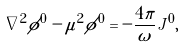Convert formula to latex. <formula><loc_0><loc_0><loc_500><loc_500>\nabla ^ { 2 } \phi ^ { 0 } - \mu ^ { 2 } \phi ^ { 0 } = - \frac { 4 \pi } { \omega } J ^ { 0 } ,</formula> 